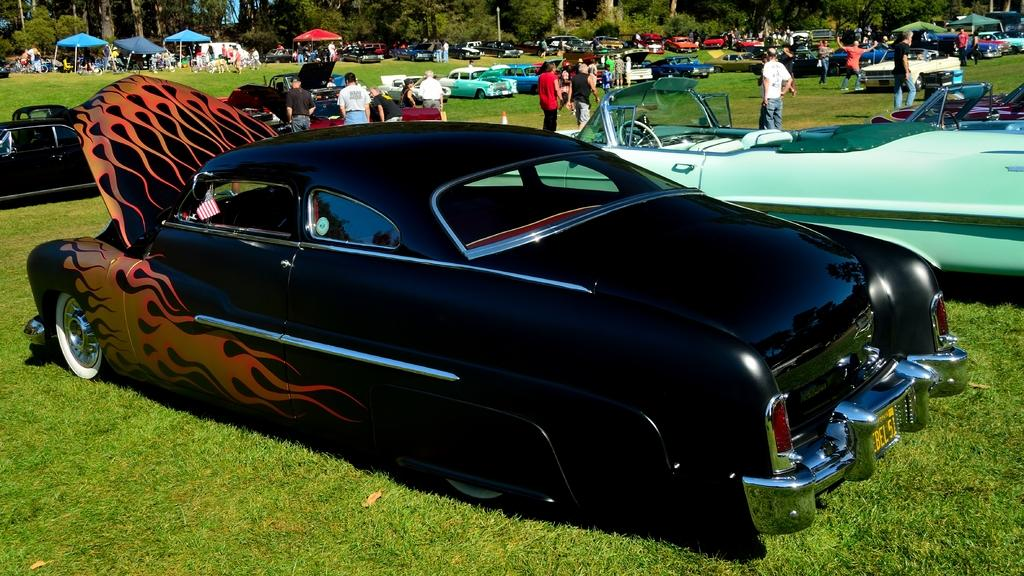What type of vegetation is present in the image? There is grass in the image. What type of vehicles can be seen in the image? There are cars in the image. Are there any human figures in the image? Yes, there are people in the image. What can be seen in the background of the image? There are trees and tents in the background of the image. Are there any cemeteries visible in the image? There is no mention of a cemetery in the provided facts, and therefore it cannot be determined if one is present in the image. Can you tell me how many bears are interacting with the people in the image? There is no mention of bears in the provided facts, and therefore it cannot be determined if any are present in the image. 